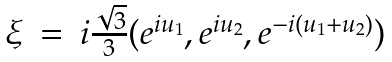<formula> <loc_0><loc_0><loc_500><loc_500>\begin{array} { l c l } \xi & = & i \frac { \sqrt { 3 } } { 3 } ( e ^ { i u _ { 1 } } , e ^ { i u _ { 2 } } , e ^ { - i ( u _ { 1 } + u _ { 2 } ) } ) \\ \end{array}</formula> 